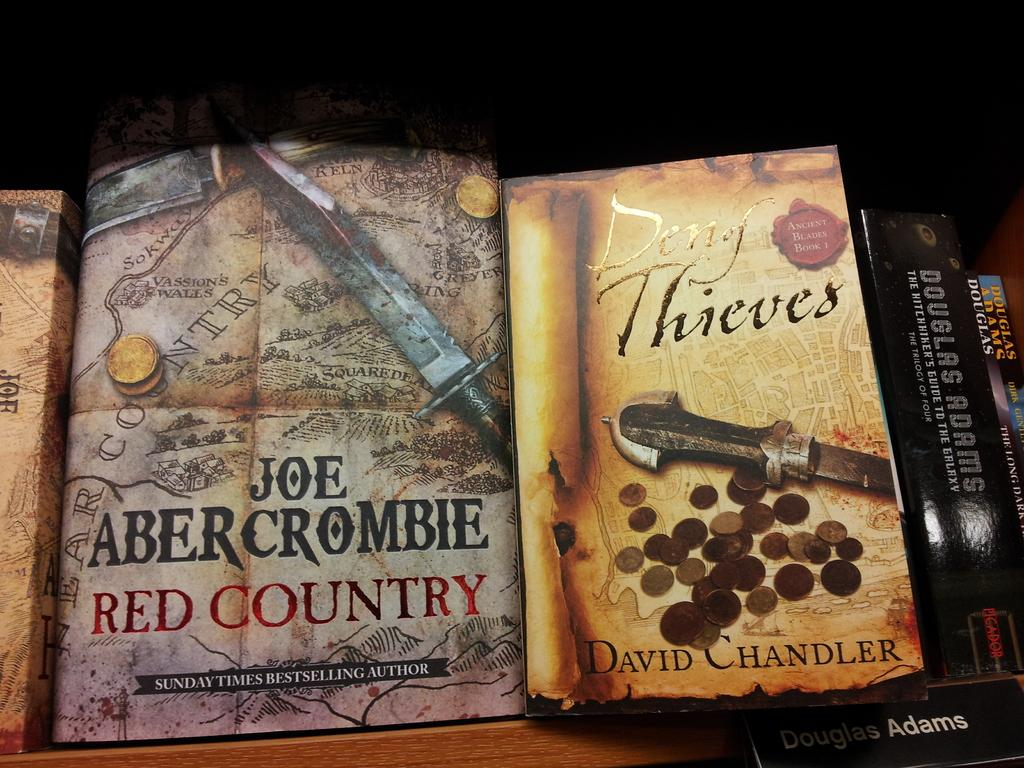Provide a one-sentence caption for the provided image. A book with the title Joe Abercorombie Red Country beside the book Deny Thieves by Davide Chandler. 